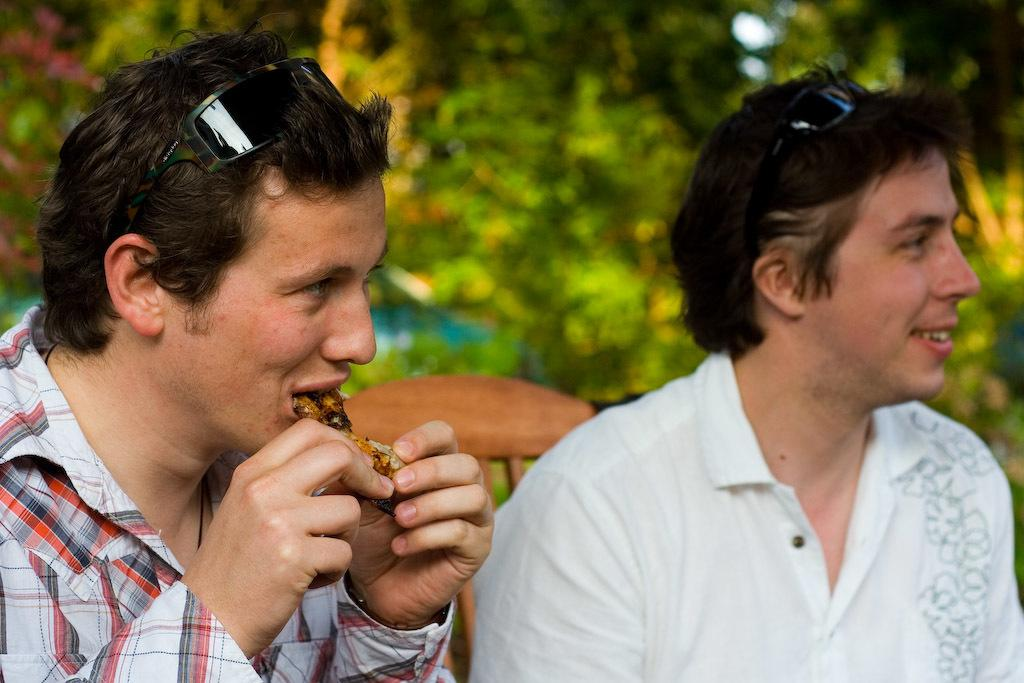How many people are in the image? There are two people in the image. What are the people doing in the image? The people are sitting on a wooden bench. Which direction are the people facing? The people are facing towards the right. What is one person doing in the image? One person on the left is having food. Can you describe the background of the image? The background is blurred. What type of bottle can be seen in the hands of the person on the right? There is no bottle present in the image; both people are sitting on a wooden bench. Can you tell me the color of the cat sitting next to the person on the left? There is no cat present in the image; the focus is on the two people sitting on the bench. 